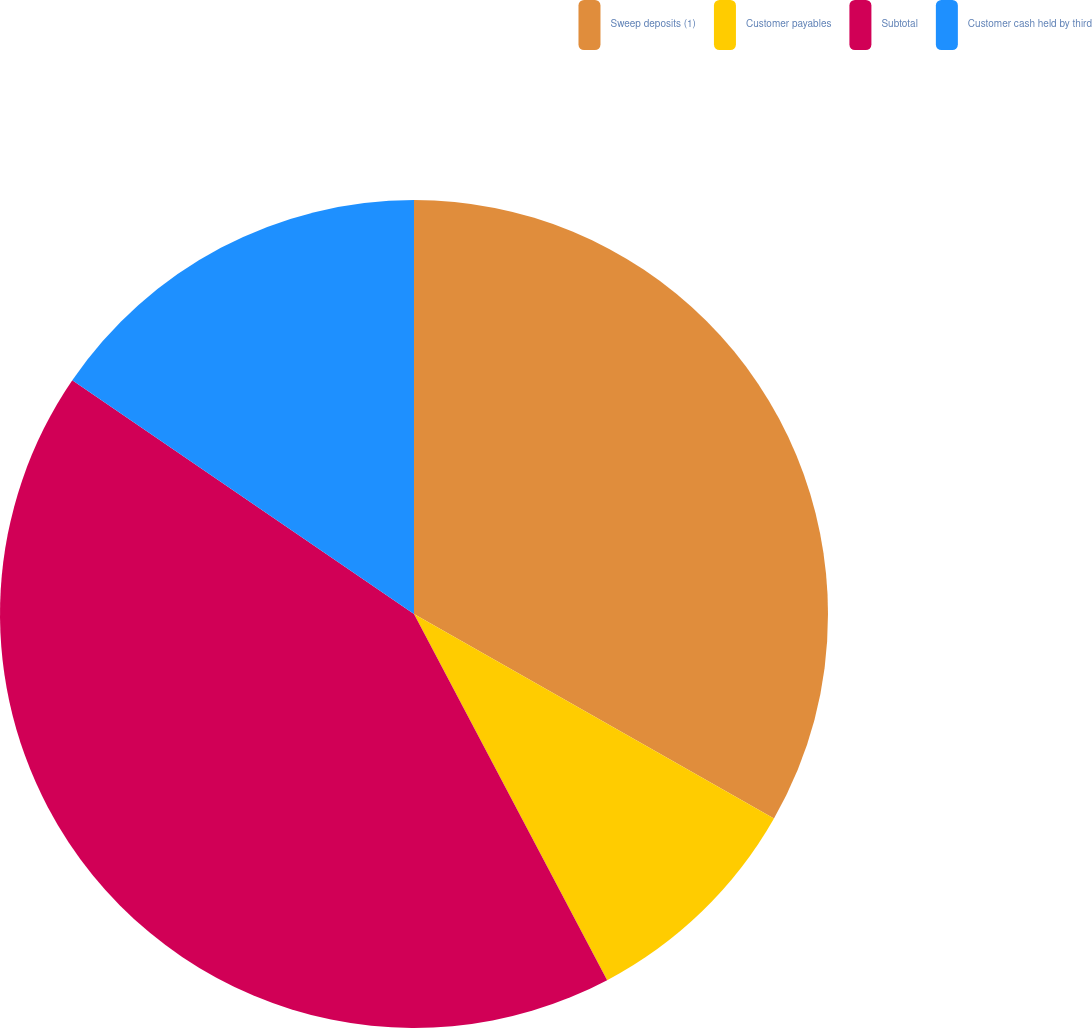Convert chart. <chart><loc_0><loc_0><loc_500><loc_500><pie_chart><fcel>Sweep deposits (1)<fcel>Customer payables<fcel>Subtotal<fcel>Customer cash held by third<nl><fcel>33.22%<fcel>9.05%<fcel>42.27%<fcel>15.45%<nl></chart> 